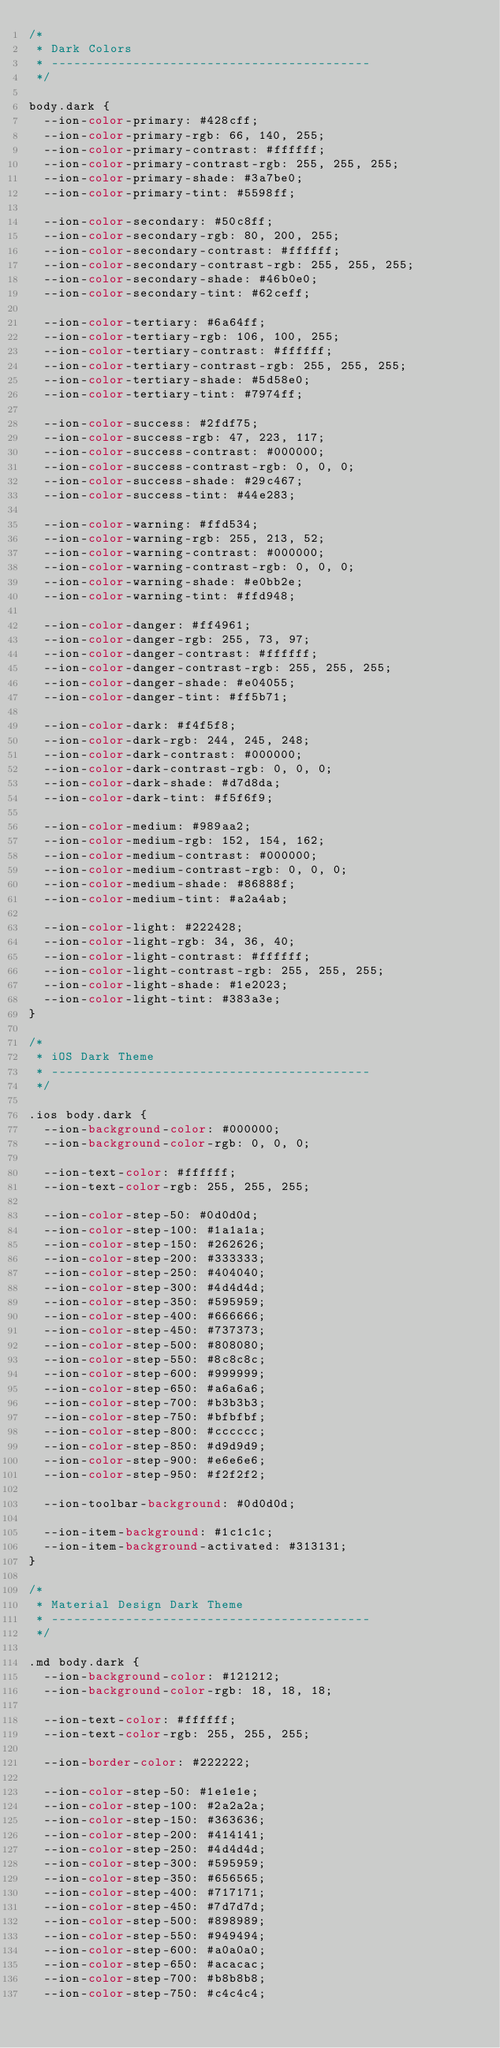Convert code to text. <code><loc_0><loc_0><loc_500><loc_500><_CSS_>/*
 * Dark Colors
 * -------------------------------------------
 */

body.dark {
  --ion-color-primary: #428cff;
  --ion-color-primary-rgb: 66, 140, 255;
  --ion-color-primary-contrast: #ffffff;
  --ion-color-primary-contrast-rgb: 255, 255, 255;
  --ion-color-primary-shade: #3a7be0;
  --ion-color-primary-tint: #5598ff;

  --ion-color-secondary: #50c8ff;
  --ion-color-secondary-rgb: 80, 200, 255;
  --ion-color-secondary-contrast: #ffffff;
  --ion-color-secondary-contrast-rgb: 255, 255, 255;
  --ion-color-secondary-shade: #46b0e0;
  --ion-color-secondary-tint: #62ceff;

  --ion-color-tertiary: #6a64ff;
  --ion-color-tertiary-rgb: 106, 100, 255;
  --ion-color-tertiary-contrast: #ffffff;
  --ion-color-tertiary-contrast-rgb: 255, 255, 255;
  --ion-color-tertiary-shade: #5d58e0;
  --ion-color-tertiary-tint: #7974ff;

  --ion-color-success: #2fdf75;
  --ion-color-success-rgb: 47, 223, 117;
  --ion-color-success-contrast: #000000;
  --ion-color-success-contrast-rgb: 0, 0, 0;
  --ion-color-success-shade: #29c467;
  --ion-color-success-tint: #44e283;

  --ion-color-warning: #ffd534;
  --ion-color-warning-rgb: 255, 213, 52;
  --ion-color-warning-contrast: #000000;
  --ion-color-warning-contrast-rgb: 0, 0, 0;
  --ion-color-warning-shade: #e0bb2e;
  --ion-color-warning-tint: #ffd948;

  --ion-color-danger: #ff4961;
  --ion-color-danger-rgb: 255, 73, 97;
  --ion-color-danger-contrast: #ffffff;
  --ion-color-danger-contrast-rgb: 255, 255, 255;
  --ion-color-danger-shade: #e04055;
  --ion-color-danger-tint: #ff5b71;

  --ion-color-dark: #f4f5f8;
  --ion-color-dark-rgb: 244, 245, 248;
  --ion-color-dark-contrast: #000000;
  --ion-color-dark-contrast-rgb: 0, 0, 0;
  --ion-color-dark-shade: #d7d8da;
  --ion-color-dark-tint: #f5f6f9;

  --ion-color-medium: #989aa2;
  --ion-color-medium-rgb: 152, 154, 162;
  --ion-color-medium-contrast: #000000;
  --ion-color-medium-contrast-rgb: 0, 0, 0;
  --ion-color-medium-shade: #86888f;
  --ion-color-medium-tint: #a2a4ab;

  --ion-color-light: #222428;
  --ion-color-light-rgb: 34, 36, 40;
  --ion-color-light-contrast: #ffffff;
  --ion-color-light-contrast-rgb: 255, 255, 255;
  --ion-color-light-shade: #1e2023;
  --ion-color-light-tint: #383a3e;
}

/*
 * iOS Dark Theme
 * -------------------------------------------
 */

.ios body.dark {
  --ion-background-color: #000000;
  --ion-background-color-rgb: 0, 0, 0;

  --ion-text-color: #ffffff;
  --ion-text-color-rgb: 255, 255, 255;

  --ion-color-step-50: #0d0d0d;
  --ion-color-step-100: #1a1a1a;
  --ion-color-step-150: #262626;
  --ion-color-step-200: #333333;
  --ion-color-step-250: #404040;
  --ion-color-step-300: #4d4d4d;
  --ion-color-step-350: #595959;
  --ion-color-step-400: #666666;
  --ion-color-step-450: #737373;
  --ion-color-step-500: #808080;
  --ion-color-step-550: #8c8c8c;
  --ion-color-step-600: #999999;
  --ion-color-step-650: #a6a6a6;
  --ion-color-step-700: #b3b3b3;
  --ion-color-step-750: #bfbfbf;
  --ion-color-step-800: #cccccc;
  --ion-color-step-850: #d9d9d9;
  --ion-color-step-900: #e6e6e6;
  --ion-color-step-950: #f2f2f2;

  --ion-toolbar-background: #0d0d0d;

  --ion-item-background: #1c1c1c;
  --ion-item-background-activated: #313131;
}

/*
 * Material Design Dark Theme
 * -------------------------------------------
 */

.md body.dark {
  --ion-background-color: #121212;
  --ion-background-color-rgb: 18, 18, 18;

  --ion-text-color: #ffffff;
  --ion-text-color-rgb: 255, 255, 255;

  --ion-border-color: #222222;

  --ion-color-step-50: #1e1e1e;
  --ion-color-step-100: #2a2a2a;
  --ion-color-step-150: #363636;
  --ion-color-step-200: #414141;
  --ion-color-step-250: #4d4d4d;
  --ion-color-step-300: #595959;
  --ion-color-step-350: #656565;
  --ion-color-step-400: #717171;
  --ion-color-step-450: #7d7d7d;
  --ion-color-step-500: #898989;
  --ion-color-step-550: #949494;
  --ion-color-step-600: #a0a0a0;
  --ion-color-step-650: #acacac;
  --ion-color-step-700: #b8b8b8;
  --ion-color-step-750: #c4c4c4;</code> 